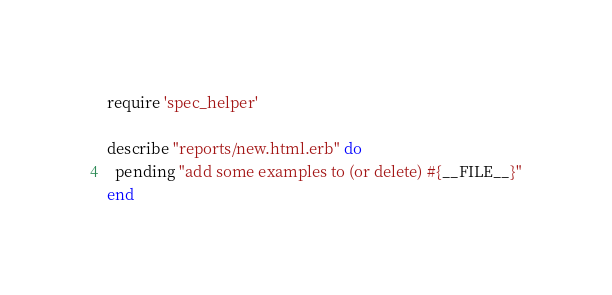<code> <loc_0><loc_0><loc_500><loc_500><_Ruby_>require 'spec_helper'

describe "reports/new.html.erb" do
  pending "add some examples to (or delete) #{__FILE__}"
end
</code> 